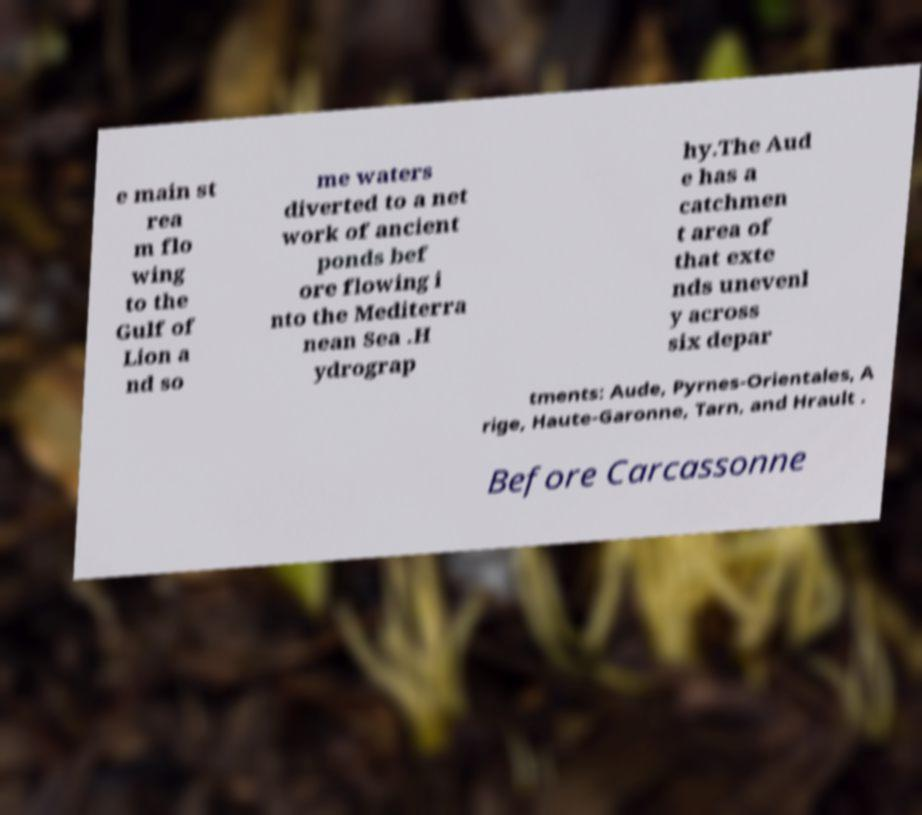Please read and relay the text visible in this image. What does it say? e main st rea m flo wing to the Gulf of Lion a nd so me waters diverted to a net work of ancient ponds bef ore flowing i nto the Mediterra nean Sea .H ydrograp hy.The Aud e has a catchmen t area of that exte nds unevenl y across six depar tments: Aude, Pyrnes-Orientales, A rige, Haute-Garonne, Tarn, and Hrault . Before Carcassonne 